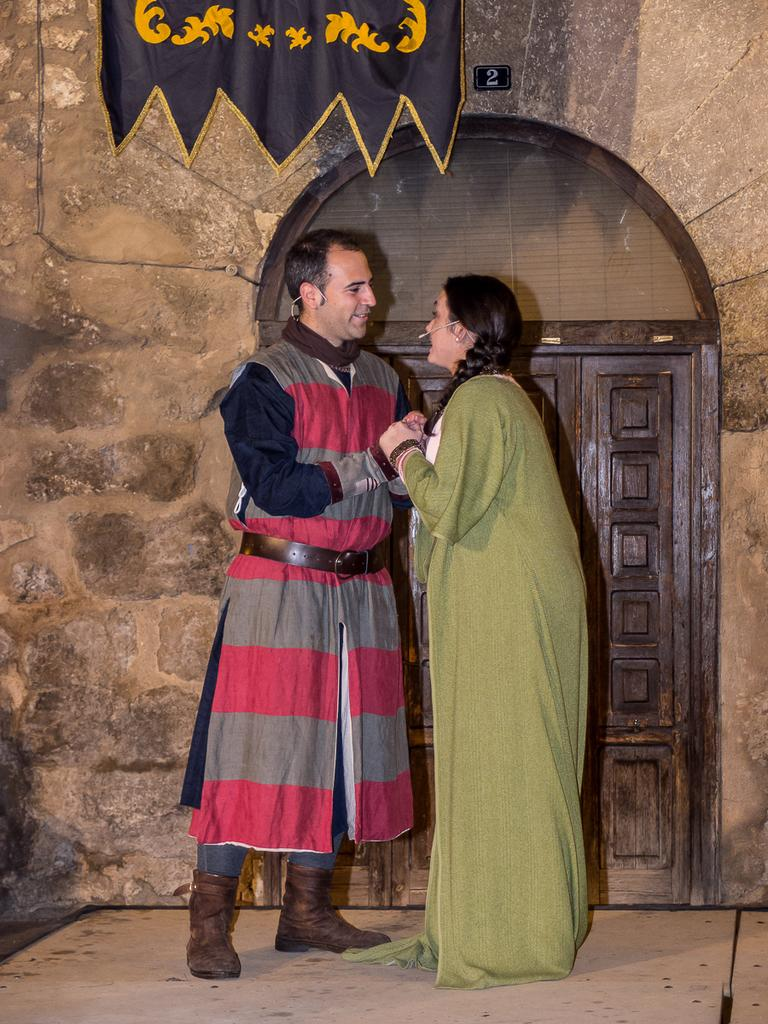Who is present in the image? There is a lady in the image. What is the lady doing in the image? The lady is holding hands with a person. What can be seen in the background of the image? There is a door, a cloth, and a wall in the image. What type of prose can be heard being recited by the dinosaurs in the image? There are no dinosaurs present in the image, and therefore no prose can be heard being recited by them. 